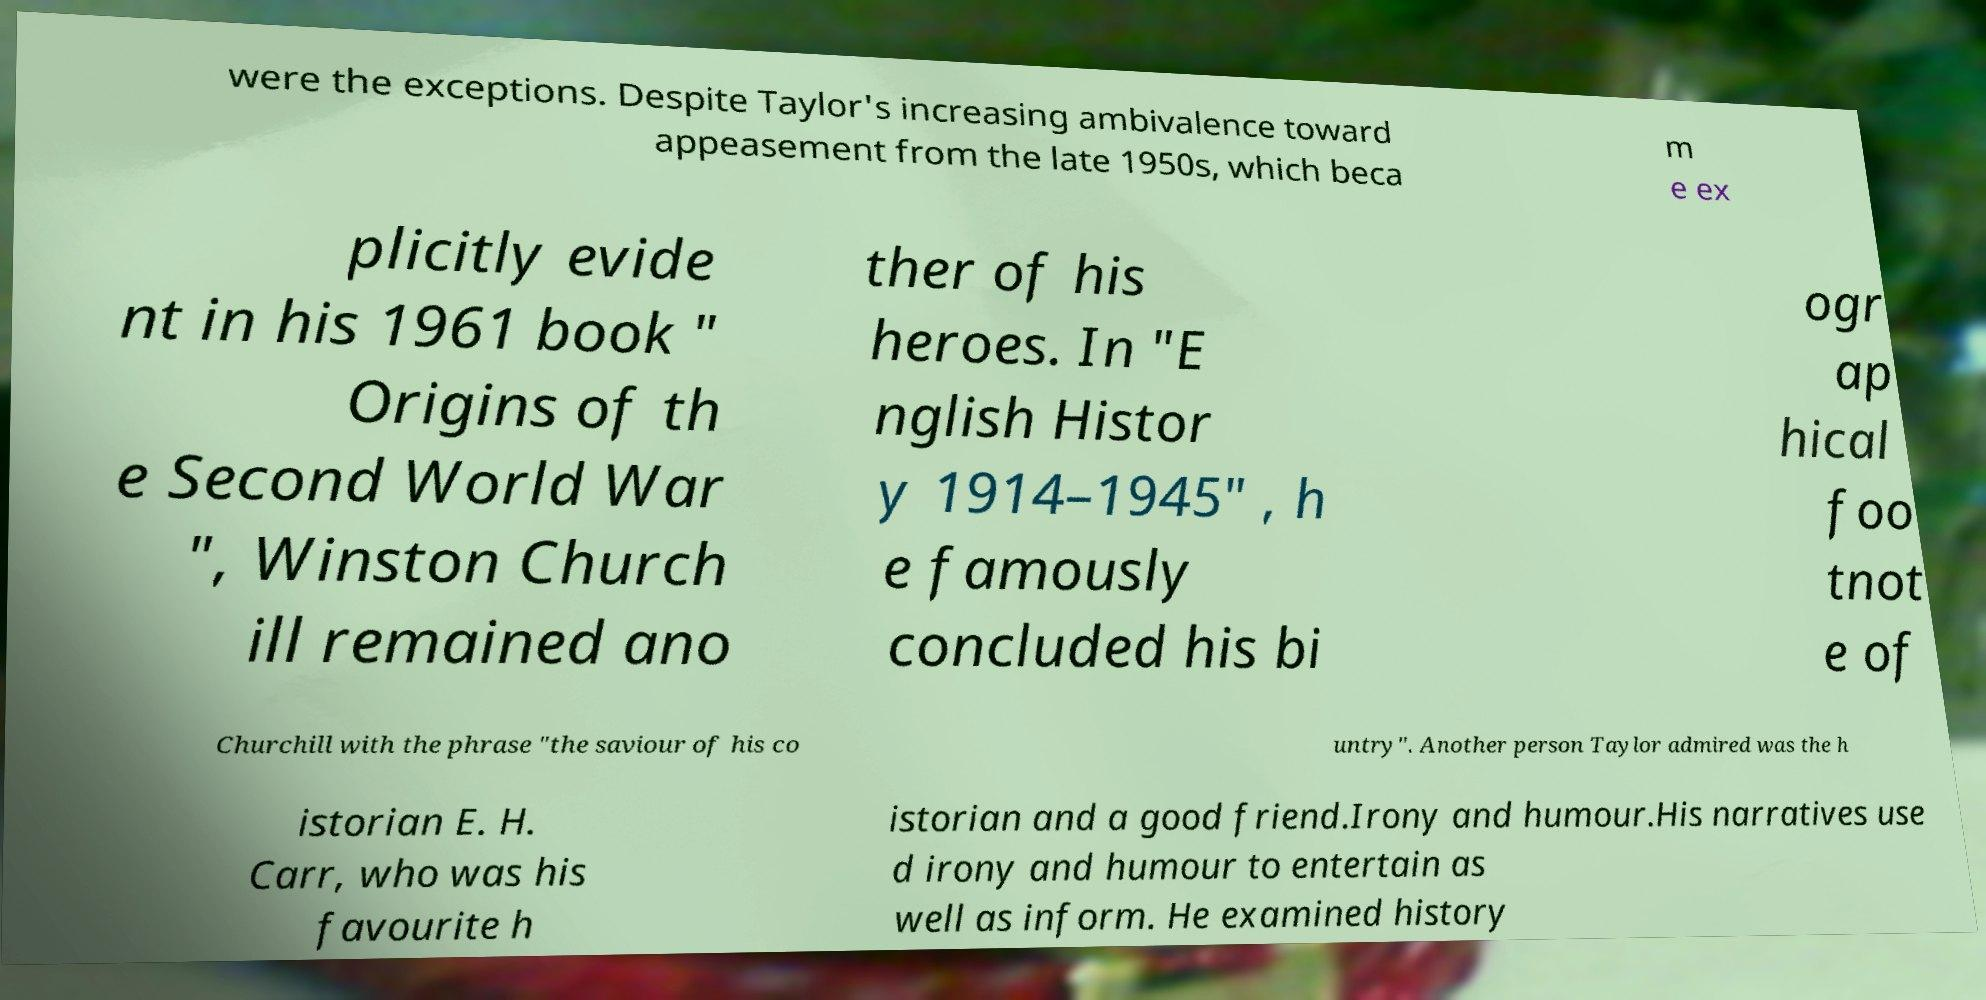For documentation purposes, I need the text within this image transcribed. Could you provide that? were the exceptions. Despite Taylor's increasing ambivalence toward appeasement from the late 1950s, which beca m e ex plicitly evide nt in his 1961 book " Origins of th e Second World War ", Winston Church ill remained ano ther of his heroes. In "E nglish Histor y 1914–1945" , h e famously concluded his bi ogr ap hical foo tnot e of Churchill with the phrase "the saviour of his co untry". Another person Taylor admired was the h istorian E. H. Carr, who was his favourite h istorian and a good friend.Irony and humour.His narratives use d irony and humour to entertain as well as inform. He examined history 